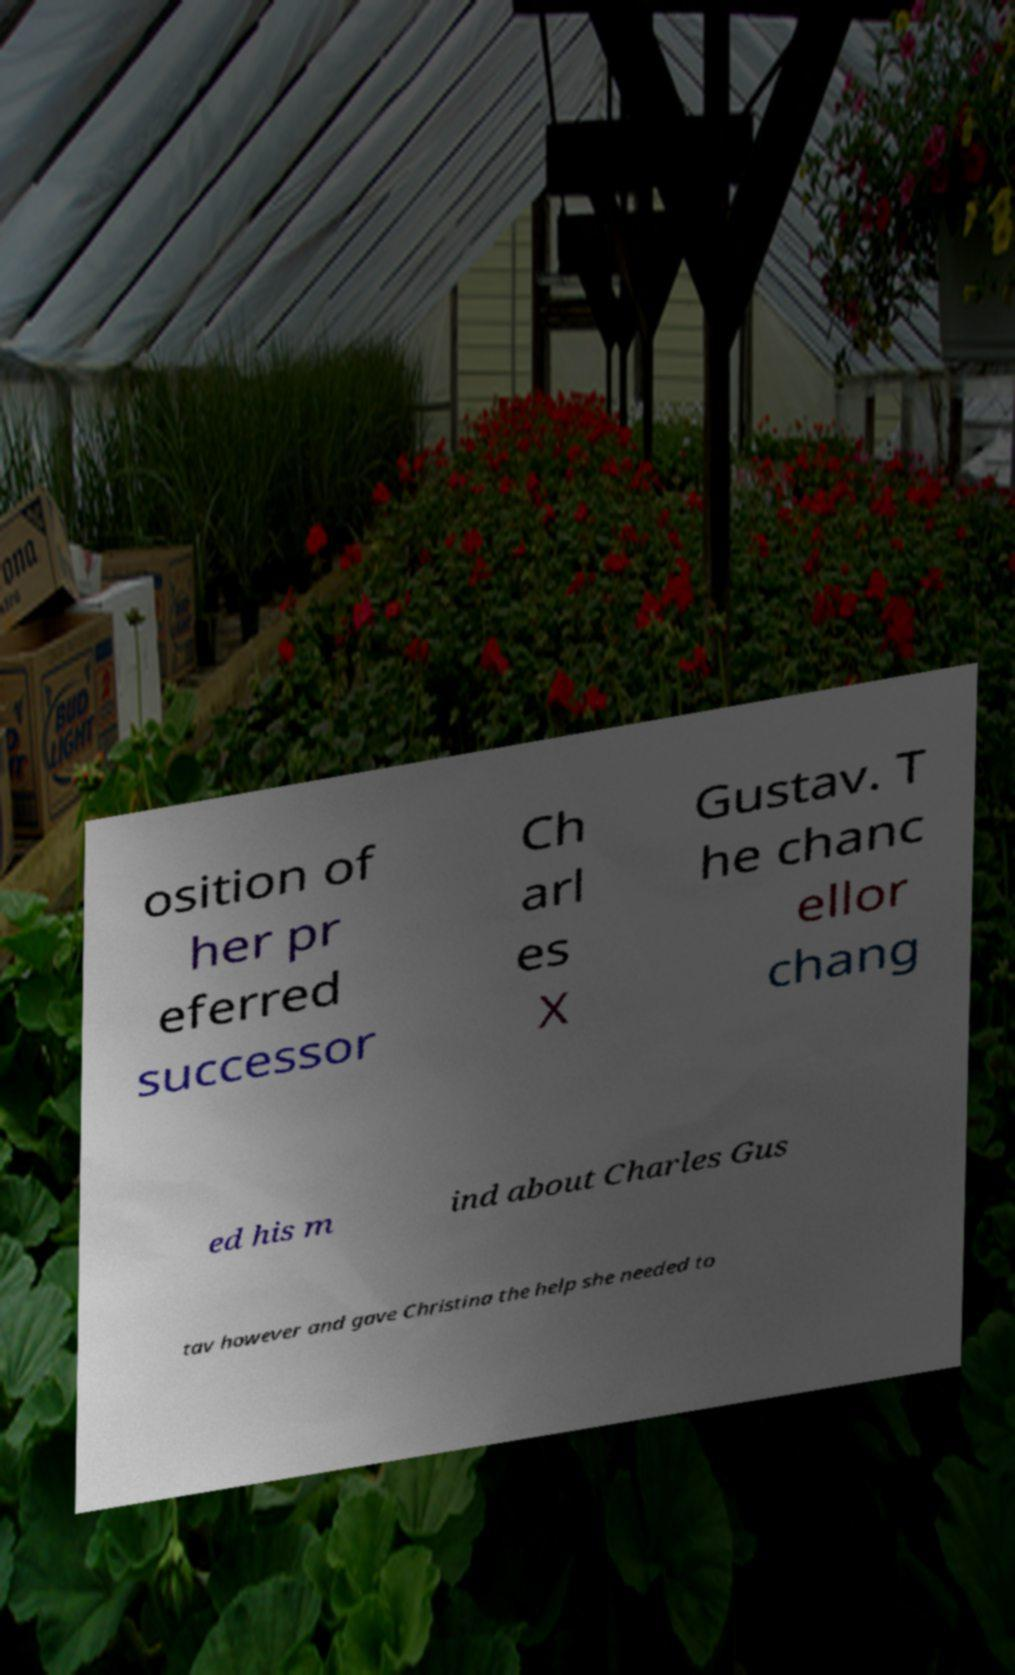Please identify and transcribe the text found in this image. osition of her pr eferred successor Ch arl es X Gustav. T he chanc ellor chang ed his m ind about Charles Gus tav however and gave Christina the help she needed to 